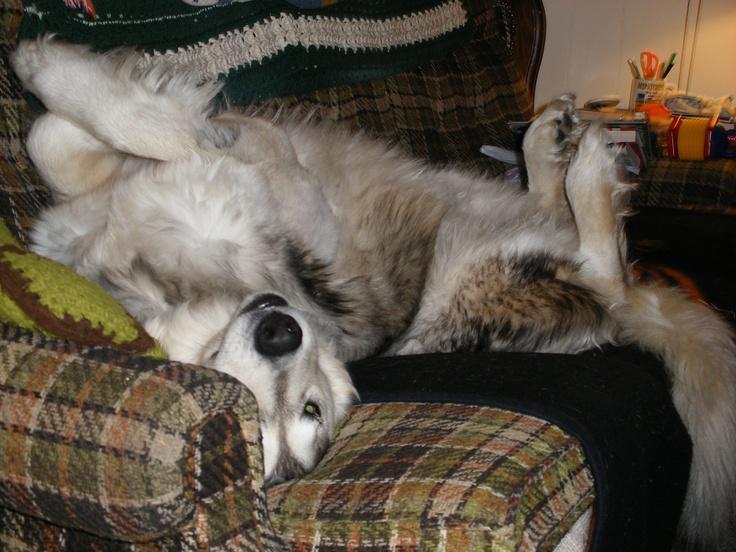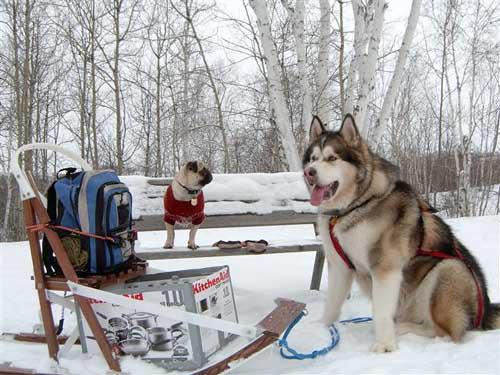The first image is the image on the left, the second image is the image on the right. Analyze the images presented: Is the assertion "The left image shows a dog in some kind of reclining pose on a sofa, and the right image includes a husky dog outdoors on snow-covered ground." valid? Answer yes or no. Yes. The first image is the image on the left, the second image is the image on the right. Given the left and right images, does the statement "There are two dogs outside." hold true? Answer yes or no. Yes. 